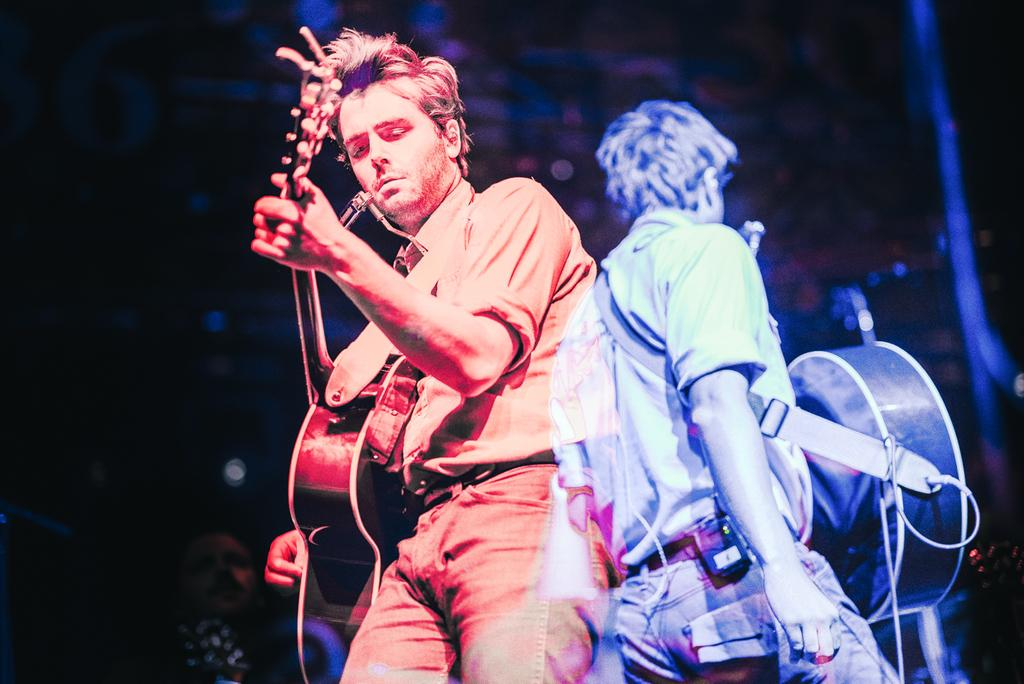How many people are in the image? There are two persons in the image. What are the two persons doing in the image? Both persons are playing guitar. What type of belief system do the guitars in the image follow? The guitars in the image do not follow any belief system, as they are inanimate objects. 